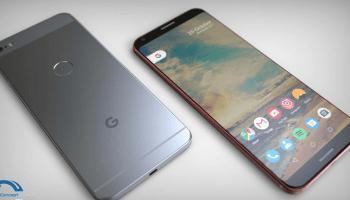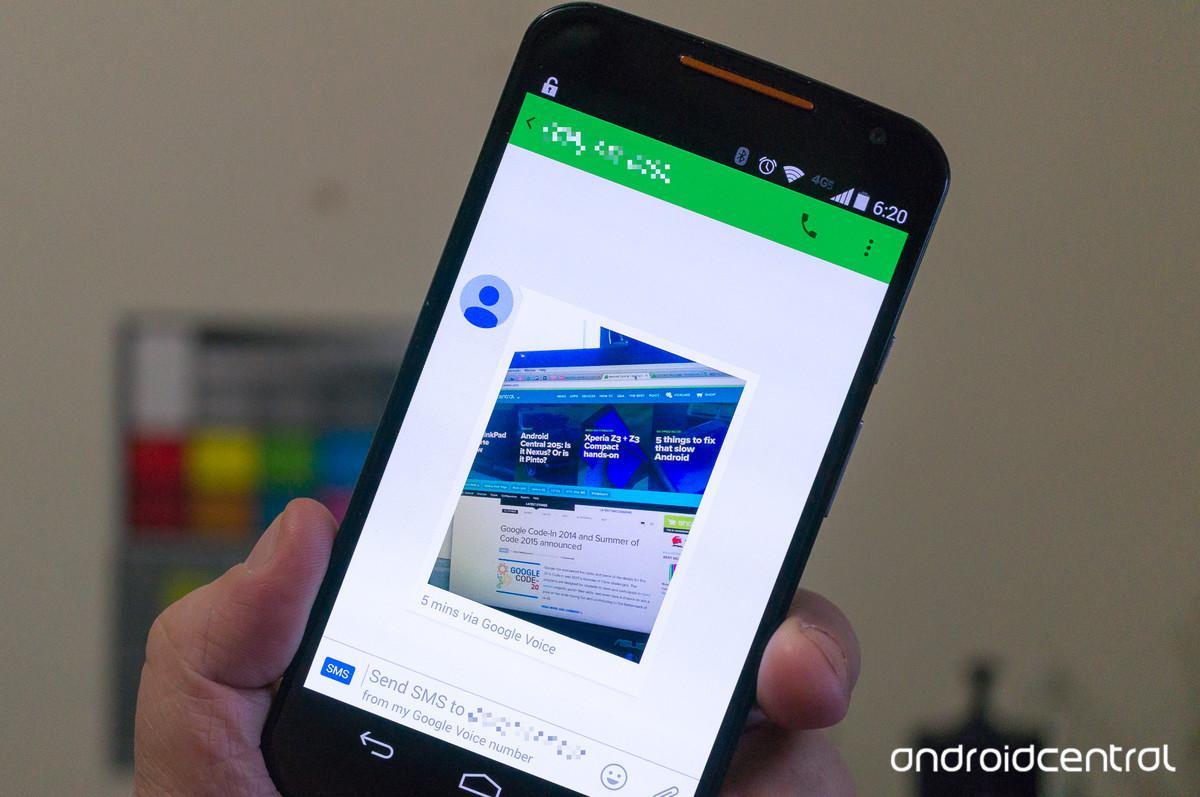The first image is the image on the left, the second image is the image on the right. Considering the images on both sides, is "A thumb is pressing the phone's screen in the image on the left." valid? Answer yes or no. No. 